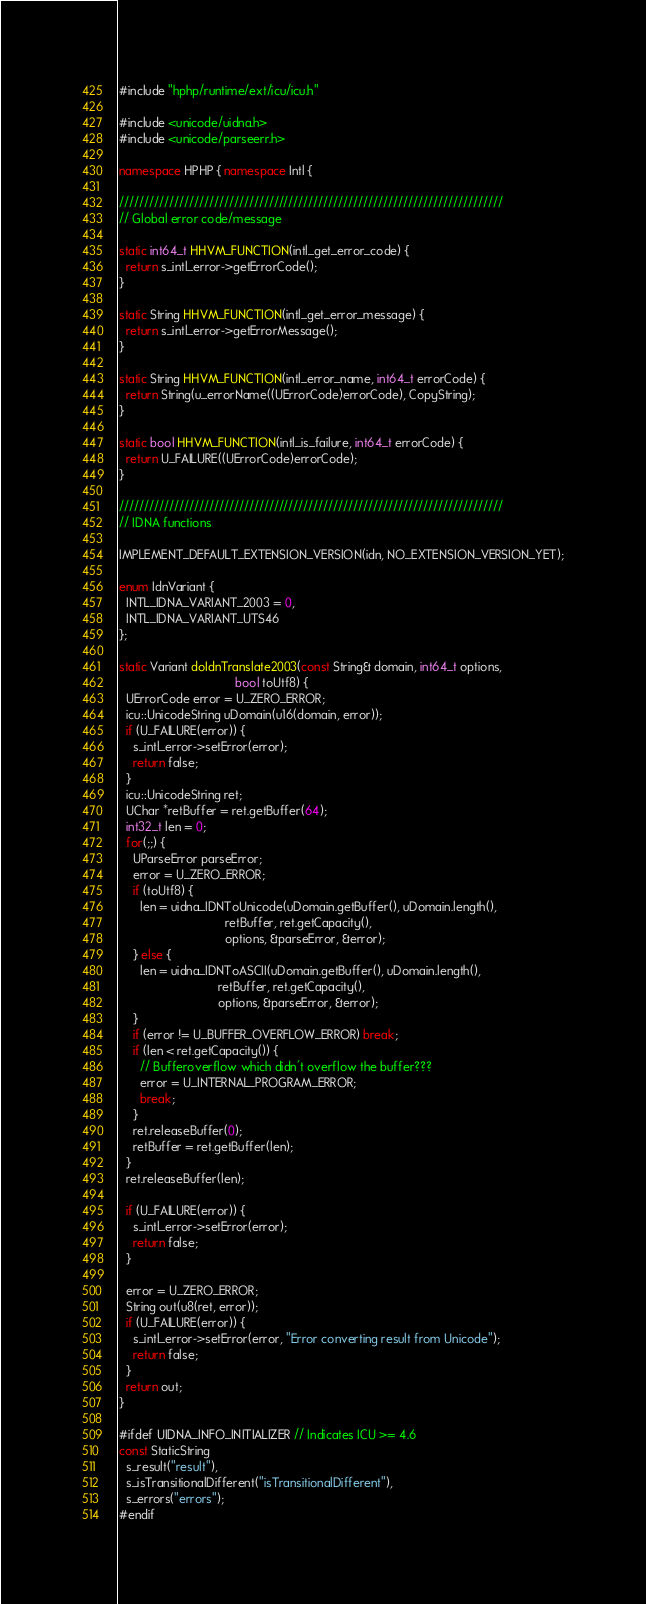<code> <loc_0><loc_0><loc_500><loc_500><_C++_>#include "hphp/runtime/ext/icu/icu.h"

#include <unicode/uidna.h>
#include <unicode/parseerr.h>

namespace HPHP { namespace Intl {

/////////////////////////////////////////////////////////////////////////////
// Global error code/message

static int64_t HHVM_FUNCTION(intl_get_error_code) {
  return s_intl_error->getErrorCode();
}

static String HHVM_FUNCTION(intl_get_error_message) {
  return s_intl_error->getErrorMessage();
}

static String HHVM_FUNCTION(intl_error_name, int64_t errorCode) {
  return String(u_errorName((UErrorCode)errorCode), CopyString);
}

static bool HHVM_FUNCTION(intl_is_failure, int64_t errorCode) {
  return U_FAILURE((UErrorCode)errorCode);
}

/////////////////////////////////////////////////////////////////////////////
// IDNA functions

IMPLEMENT_DEFAULT_EXTENSION_VERSION(idn, NO_EXTENSION_VERSION_YET);

enum IdnVariant {
  INTL_IDNA_VARIANT_2003 = 0,
  INTL_IDNA_VARIANT_UTS46
};

static Variant doIdnTranslate2003(const String& domain, int64_t options,
                                  bool toUtf8) {
  UErrorCode error = U_ZERO_ERROR;
  icu::UnicodeString uDomain(u16(domain, error));
  if (U_FAILURE(error)) {
    s_intl_error->setError(error);
    return false;
  }
  icu::UnicodeString ret;
  UChar *retBuffer = ret.getBuffer(64);
  int32_t len = 0;
  for(;;) {
    UParseError parseError;
    error = U_ZERO_ERROR;
    if (toUtf8) {
      len = uidna_IDNToUnicode(uDomain.getBuffer(), uDomain.length(),
                               retBuffer, ret.getCapacity(),
                               options, &parseError, &error);
    } else {
      len = uidna_IDNToASCII(uDomain.getBuffer(), uDomain.length(),
                             retBuffer, ret.getCapacity(),
                             options, &parseError, &error);
    }
    if (error != U_BUFFER_OVERFLOW_ERROR) break;
    if (len < ret.getCapacity()) {
      // Bufferoverflow which didn't overflow the buffer???
      error = U_INTERNAL_PROGRAM_ERROR;
      break;
    }
    ret.releaseBuffer(0);
    retBuffer = ret.getBuffer(len);
  }
  ret.releaseBuffer(len);

  if (U_FAILURE(error)) {
    s_intl_error->setError(error);
    return false;
  }

  error = U_ZERO_ERROR;
  String out(u8(ret, error));
  if (U_FAILURE(error)) {
    s_intl_error->setError(error, "Error converting result from Unicode");
    return false;
  }
  return out;
}

#ifdef UIDNA_INFO_INITIALIZER // Indicates ICU >= 4.6
const StaticString
  s_result("result"),
  s_isTransitionalDifferent("isTransitionalDifferent"),
  s_errors("errors");
#endif
</code> 